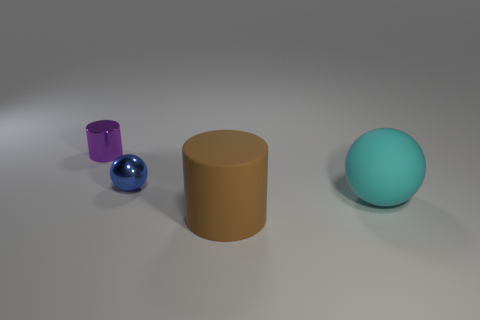How many tiny cylinders are the same material as the blue thing?
Your answer should be compact. 1. How many cyan rubber things are behind the tiny blue sphere?
Your answer should be very brief. 0. Are the cylinder that is right of the tiny purple metallic thing and the cylinder on the left side of the large cylinder made of the same material?
Your answer should be very brief. No. Is the number of small purple cylinders that are on the right side of the metal cylinder greater than the number of tiny purple objects in front of the big cylinder?
Provide a short and direct response. No. Is there anything else that is the same shape as the blue object?
Your answer should be compact. Yes. The thing that is right of the small ball and left of the cyan matte sphere is made of what material?
Keep it short and to the point. Rubber. Does the large cyan ball have the same material as the sphere that is to the left of the large brown matte cylinder?
Your response must be concise. No. Is there any other thing that has the same size as the cyan rubber object?
Provide a succinct answer. Yes. How many objects are either small metallic cylinders or objects that are left of the cyan ball?
Give a very brief answer. 3. Is the size of the object that is right of the brown matte cylinder the same as the cylinder that is to the left of the blue shiny object?
Provide a succinct answer. No. 